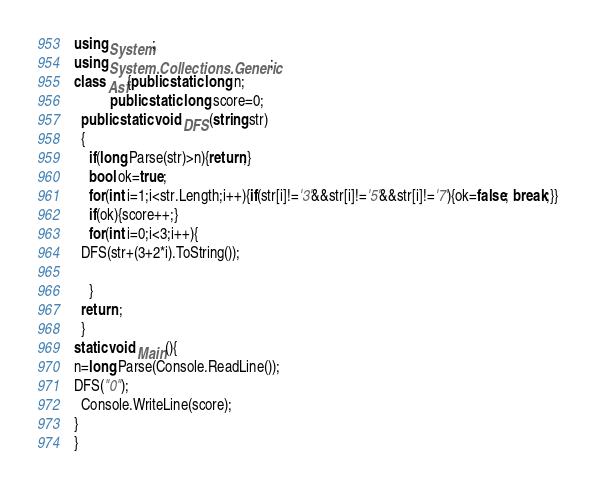<code> <loc_0><loc_0><loc_500><loc_500><_C#_>using System;
using System.Collections.Generic;
class Asf{public static long n;
          public static long score=0;
  public static void DFS(string str)
  {
    if(long.Parse(str)>n){return;}
    bool ok=true;
    for(int i=1;i<str.Length;i++){if(str[i]!='3'&&str[i]!='5'&&str[i]!='7'){ok=false; break;}}
	if(ok){score++;}
    for(int i=0;i<3;i++){
  DFS(str+(3+2*i).ToString());
  
    }
  return ;
  }
static void Main(){
n=long.Parse(Console.ReadLine());
DFS("0");
  Console.WriteLine(score);
}
}
</code> 